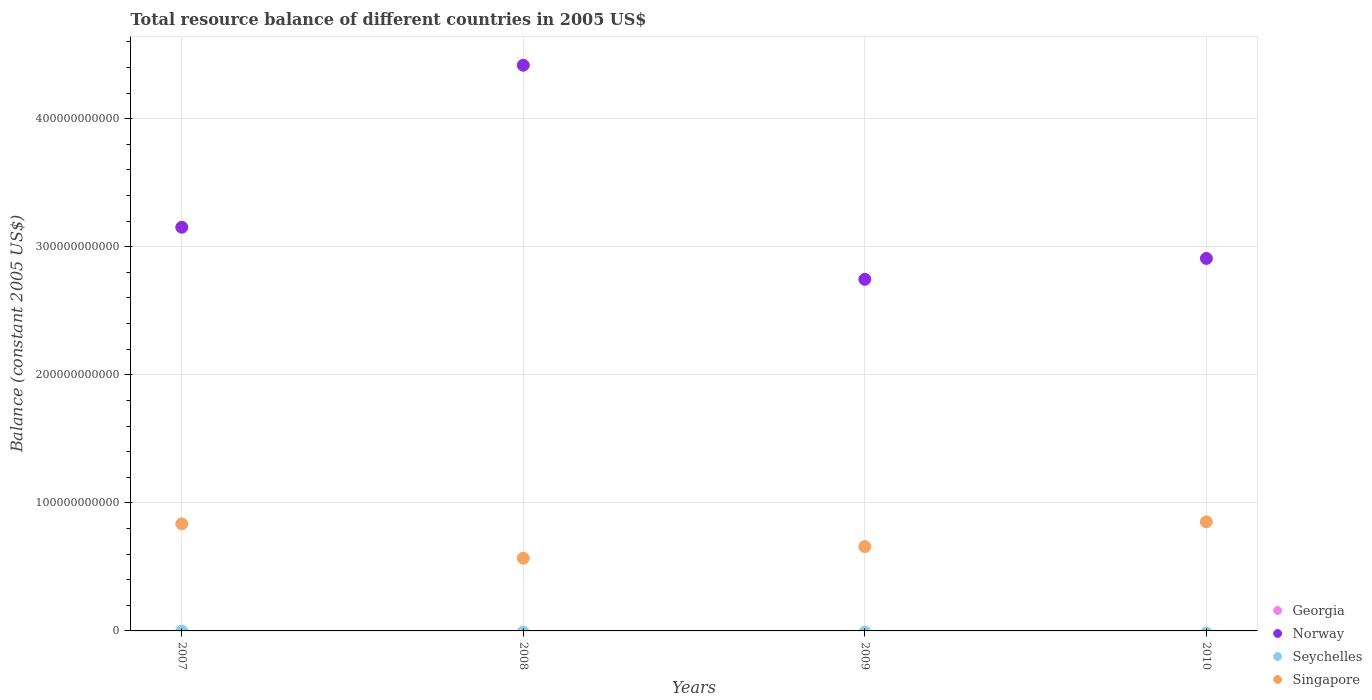How many different coloured dotlines are there?
Offer a very short reply. 2. What is the total resource balance in Georgia in 2010?
Your answer should be compact. 0. Across all years, what is the maximum total resource balance in Norway?
Offer a very short reply. 4.42e+11. Across all years, what is the minimum total resource balance in Norway?
Offer a very short reply. 2.75e+11. In which year was the total resource balance in Norway maximum?
Provide a short and direct response. 2008. What is the total total resource balance in Norway in the graph?
Your answer should be very brief. 1.32e+12. What is the difference between the total resource balance in Norway in 2008 and that in 2009?
Make the answer very short. 1.67e+11. What is the difference between the total resource balance in Singapore in 2009 and the total resource balance in Georgia in 2010?
Your answer should be compact. 6.58e+1. What is the average total resource balance in Norway per year?
Offer a terse response. 3.31e+11. In the year 2008, what is the difference between the total resource balance in Norway and total resource balance in Singapore?
Keep it short and to the point. 3.85e+11. What is the ratio of the total resource balance in Singapore in 2007 to that in 2008?
Keep it short and to the point. 1.47. What is the difference between the highest and the second highest total resource balance in Singapore?
Provide a short and direct response. 1.55e+09. What is the difference between the highest and the lowest total resource balance in Singapore?
Keep it short and to the point. 2.84e+1. In how many years, is the total resource balance in Norway greater than the average total resource balance in Norway taken over all years?
Offer a very short reply. 1. Is it the case that in every year, the sum of the total resource balance in Singapore and total resource balance in Norway  is greater than the total resource balance in Georgia?
Make the answer very short. Yes. How many dotlines are there?
Keep it short and to the point. 2. How many years are there in the graph?
Offer a very short reply. 4. What is the difference between two consecutive major ticks on the Y-axis?
Ensure brevity in your answer.  1.00e+11. How many legend labels are there?
Your response must be concise. 4. How are the legend labels stacked?
Make the answer very short. Vertical. What is the title of the graph?
Provide a succinct answer. Total resource balance of different countries in 2005 US$. Does "Eritrea" appear as one of the legend labels in the graph?
Make the answer very short. No. What is the label or title of the Y-axis?
Your response must be concise. Balance (constant 2005 US$). What is the Balance (constant 2005 US$) in Norway in 2007?
Give a very brief answer. 3.15e+11. What is the Balance (constant 2005 US$) of Singapore in 2007?
Provide a succinct answer. 8.36e+1. What is the Balance (constant 2005 US$) of Georgia in 2008?
Offer a very short reply. 0. What is the Balance (constant 2005 US$) of Norway in 2008?
Keep it short and to the point. 4.42e+11. What is the Balance (constant 2005 US$) of Seychelles in 2008?
Provide a short and direct response. 0. What is the Balance (constant 2005 US$) in Singapore in 2008?
Offer a terse response. 5.68e+1. What is the Balance (constant 2005 US$) of Norway in 2009?
Make the answer very short. 2.75e+11. What is the Balance (constant 2005 US$) of Singapore in 2009?
Make the answer very short. 6.58e+1. What is the Balance (constant 2005 US$) in Norway in 2010?
Give a very brief answer. 2.91e+11. What is the Balance (constant 2005 US$) of Seychelles in 2010?
Your answer should be compact. 0. What is the Balance (constant 2005 US$) of Singapore in 2010?
Offer a terse response. 8.52e+1. Across all years, what is the maximum Balance (constant 2005 US$) of Norway?
Provide a short and direct response. 4.42e+11. Across all years, what is the maximum Balance (constant 2005 US$) in Singapore?
Your response must be concise. 8.52e+1. Across all years, what is the minimum Balance (constant 2005 US$) in Norway?
Offer a very short reply. 2.75e+11. Across all years, what is the minimum Balance (constant 2005 US$) of Singapore?
Your answer should be compact. 5.68e+1. What is the total Balance (constant 2005 US$) in Georgia in the graph?
Provide a succinct answer. 0. What is the total Balance (constant 2005 US$) in Norway in the graph?
Provide a short and direct response. 1.32e+12. What is the total Balance (constant 2005 US$) of Seychelles in the graph?
Keep it short and to the point. 0. What is the total Balance (constant 2005 US$) of Singapore in the graph?
Your response must be concise. 2.91e+11. What is the difference between the Balance (constant 2005 US$) in Norway in 2007 and that in 2008?
Ensure brevity in your answer.  -1.27e+11. What is the difference between the Balance (constant 2005 US$) in Singapore in 2007 and that in 2008?
Provide a short and direct response. 2.68e+1. What is the difference between the Balance (constant 2005 US$) in Norway in 2007 and that in 2009?
Provide a succinct answer. 4.06e+1. What is the difference between the Balance (constant 2005 US$) of Singapore in 2007 and that in 2009?
Provide a succinct answer. 1.78e+1. What is the difference between the Balance (constant 2005 US$) in Norway in 2007 and that in 2010?
Offer a terse response. 2.44e+1. What is the difference between the Balance (constant 2005 US$) in Singapore in 2007 and that in 2010?
Ensure brevity in your answer.  -1.55e+09. What is the difference between the Balance (constant 2005 US$) of Norway in 2008 and that in 2009?
Give a very brief answer. 1.67e+11. What is the difference between the Balance (constant 2005 US$) of Singapore in 2008 and that in 2009?
Keep it short and to the point. -9.06e+09. What is the difference between the Balance (constant 2005 US$) of Norway in 2008 and that in 2010?
Provide a succinct answer. 1.51e+11. What is the difference between the Balance (constant 2005 US$) in Singapore in 2008 and that in 2010?
Keep it short and to the point. -2.84e+1. What is the difference between the Balance (constant 2005 US$) in Norway in 2009 and that in 2010?
Keep it short and to the point. -1.63e+1. What is the difference between the Balance (constant 2005 US$) of Singapore in 2009 and that in 2010?
Make the answer very short. -1.93e+1. What is the difference between the Balance (constant 2005 US$) of Norway in 2007 and the Balance (constant 2005 US$) of Singapore in 2008?
Make the answer very short. 2.58e+11. What is the difference between the Balance (constant 2005 US$) in Norway in 2007 and the Balance (constant 2005 US$) in Singapore in 2009?
Make the answer very short. 2.49e+11. What is the difference between the Balance (constant 2005 US$) in Norway in 2007 and the Balance (constant 2005 US$) in Singapore in 2010?
Your answer should be compact. 2.30e+11. What is the difference between the Balance (constant 2005 US$) in Norway in 2008 and the Balance (constant 2005 US$) in Singapore in 2009?
Make the answer very short. 3.76e+11. What is the difference between the Balance (constant 2005 US$) of Norway in 2008 and the Balance (constant 2005 US$) of Singapore in 2010?
Keep it short and to the point. 3.57e+11. What is the difference between the Balance (constant 2005 US$) of Norway in 2009 and the Balance (constant 2005 US$) of Singapore in 2010?
Offer a very short reply. 1.89e+11. What is the average Balance (constant 2005 US$) in Norway per year?
Offer a very short reply. 3.31e+11. What is the average Balance (constant 2005 US$) in Seychelles per year?
Provide a short and direct response. 0. What is the average Balance (constant 2005 US$) in Singapore per year?
Your answer should be compact. 7.29e+1. In the year 2007, what is the difference between the Balance (constant 2005 US$) in Norway and Balance (constant 2005 US$) in Singapore?
Provide a succinct answer. 2.32e+11. In the year 2008, what is the difference between the Balance (constant 2005 US$) of Norway and Balance (constant 2005 US$) of Singapore?
Your response must be concise. 3.85e+11. In the year 2009, what is the difference between the Balance (constant 2005 US$) in Norway and Balance (constant 2005 US$) in Singapore?
Make the answer very short. 2.09e+11. In the year 2010, what is the difference between the Balance (constant 2005 US$) of Norway and Balance (constant 2005 US$) of Singapore?
Give a very brief answer. 2.06e+11. What is the ratio of the Balance (constant 2005 US$) in Norway in 2007 to that in 2008?
Offer a very short reply. 0.71. What is the ratio of the Balance (constant 2005 US$) in Singapore in 2007 to that in 2008?
Your response must be concise. 1.47. What is the ratio of the Balance (constant 2005 US$) of Norway in 2007 to that in 2009?
Your answer should be compact. 1.15. What is the ratio of the Balance (constant 2005 US$) in Singapore in 2007 to that in 2009?
Your answer should be very brief. 1.27. What is the ratio of the Balance (constant 2005 US$) of Norway in 2007 to that in 2010?
Make the answer very short. 1.08. What is the ratio of the Balance (constant 2005 US$) of Singapore in 2007 to that in 2010?
Offer a very short reply. 0.98. What is the ratio of the Balance (constant 2005 US$) of Norway in 2008 to that in 2009?
Your answer should be very brief. 1.61. What is the ratio of the Balance (constant 2005 US$) in Singapore in 2008 to that in 2009?
Provide a succinct answer. 0.86. What is the ratio of the Balance (constant 2005 US$) of Norway in 2008 to that in 2010?
Your answer should be very brief. 1.52. What is the ratio of the Balance (constant 2005 US$) in Singapore in 2008 to that in 2010?
Your answer should be very brief. 0.67. What is the ratio of the Balance (constant 2005 US$) in Norway in 2009 to that in 2010?
Your answer should be very brief. 0.94. What is the ratio of the Balance (constant 2005 US$) of Singapore in 2009 to that in 2010?
Make the answer very short. 0.77. What is the difference between the highest and the second highest Balance (constant 2005 US$) of Norway?
Offer a very short reply. 1.27e+11. What is the difference between the highest and the second highest Balance (constant 2005 US$) in Singapore?
Offer a very short reply. 1.55e+09. What is the difference between the highest and the lowest Balance (constant 2005 US$) of Norway?
Your answer should be compact. 1.67e+11. What is the difference between the highest and the lowest Balance (constant 2005 US$) in Singapore?
Keep it short and to the point. 2.84e+1. 